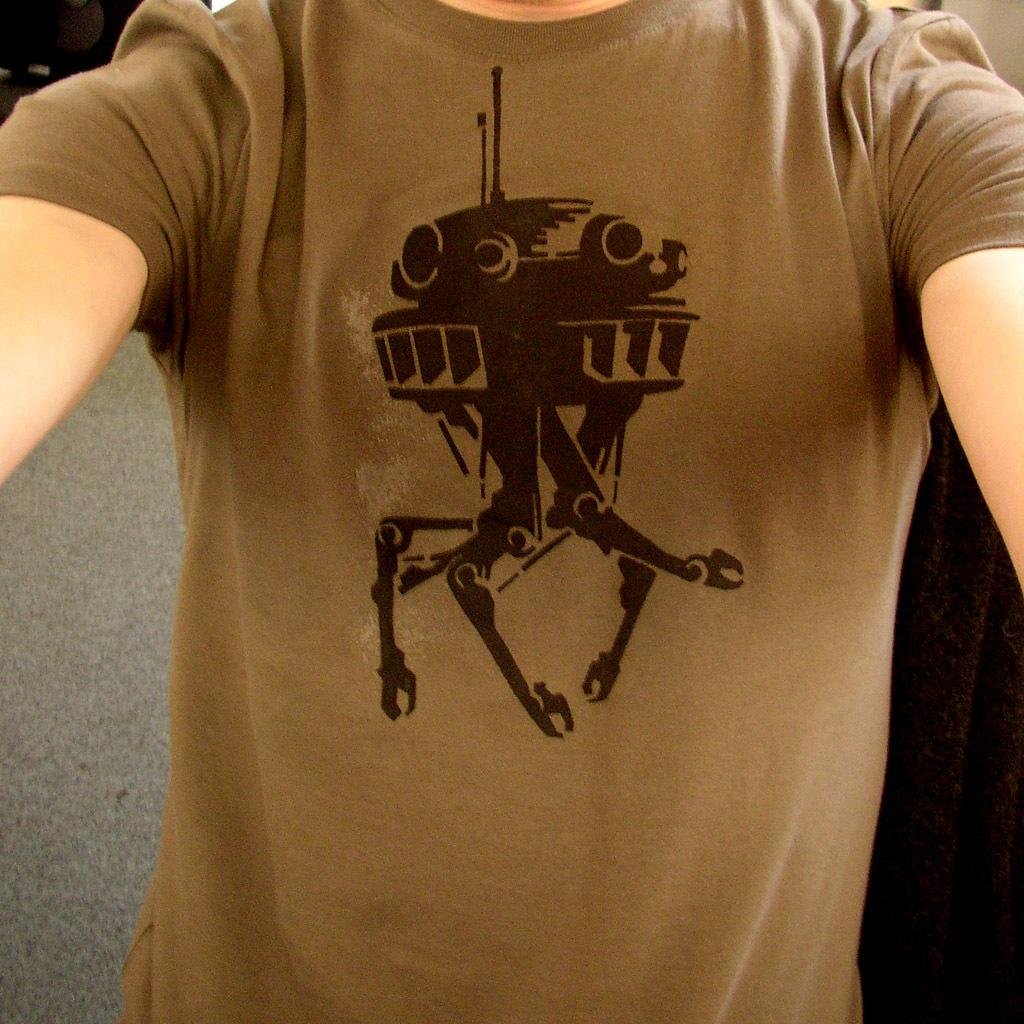What is the main subject of the image? The main subject of the image is the body of a person. What is the person wearing in the image? The person is wearing a t-shirt with a print on it. What type of quilt is draped over the person's legs in the image? There is no quilt present in the image; the person is only wearing a t-shirt. What day of the week is shown on the calendar in the image? There is no calendar present in the image. 